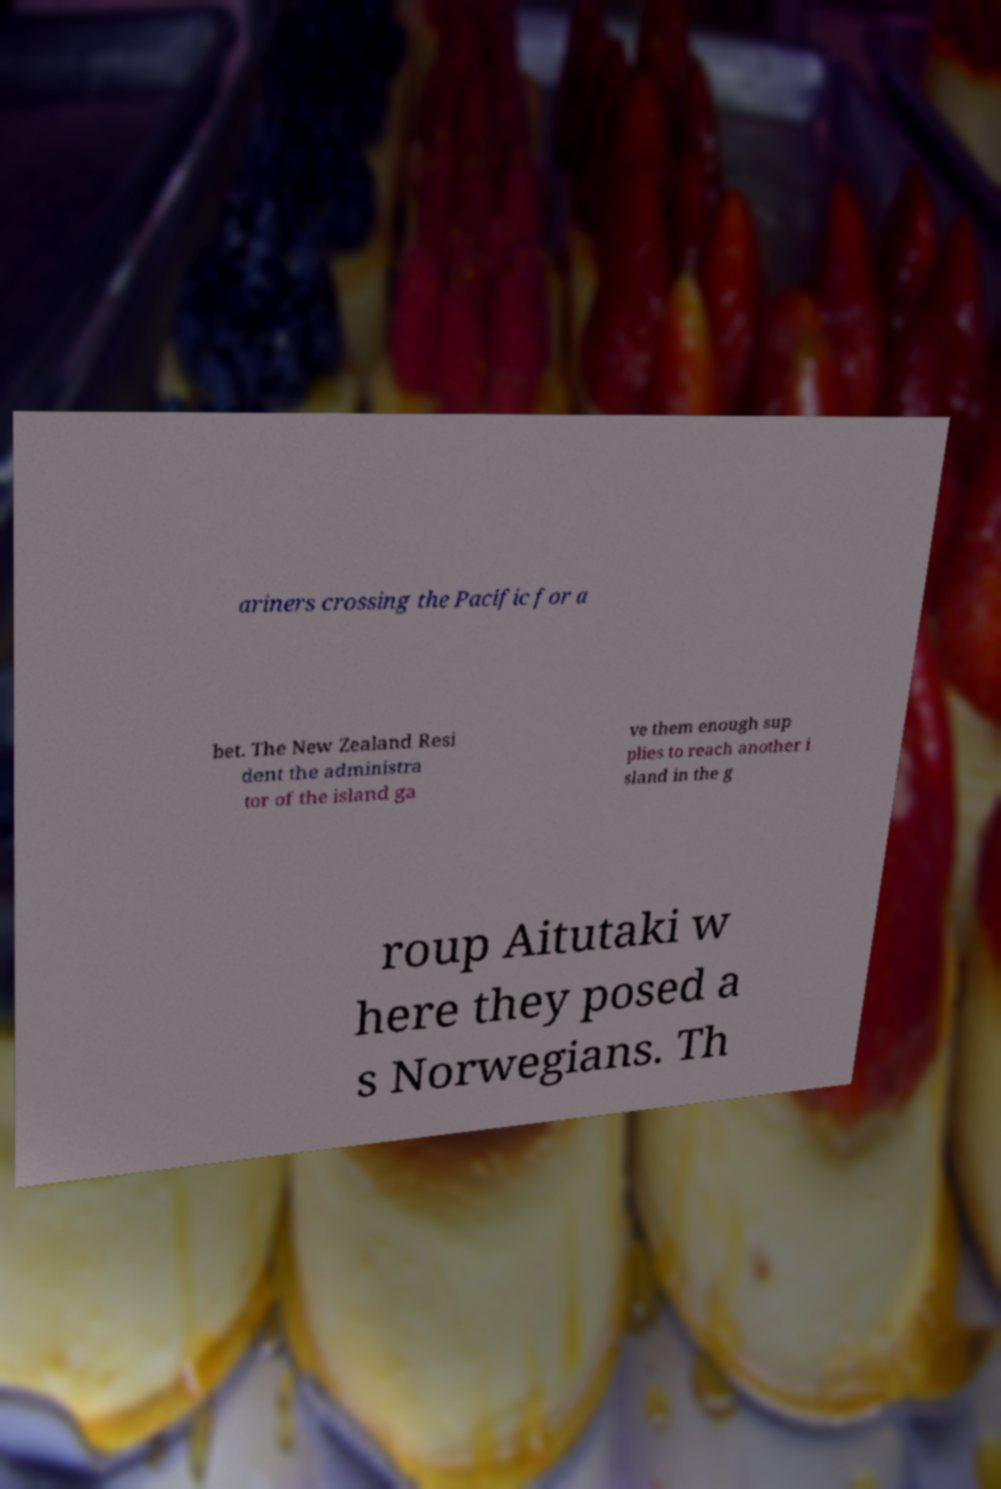Please identify and transcribe the text found in this image. ariners crossing the Pacific for a bet. The New Zealand Resi dent the administra tor of the island ga ve them enough sup plies to reach another i sland in the g roup Aitutaki w here they posed a s Norwegians. Th 